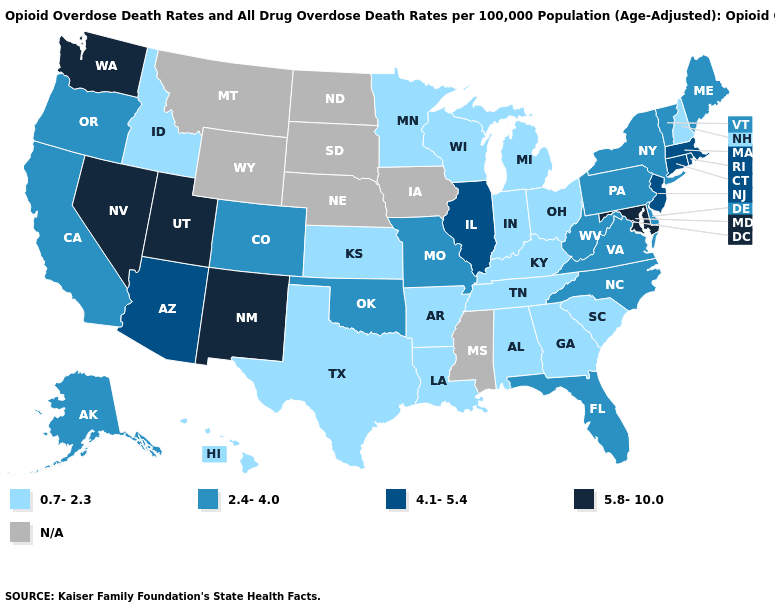What is the value of Louisiana?
Quick response, please. 0.7-2.3. Does the first symbol in the legend represent the smallest category?
Short answer required. Yes. Among the states that border Missouri , does Kentucky have the highest value?
Short answer required. No. What is the highest value in the USA?
Short answer required. 5.8-10.0. What is the highest value in states that border Maryland?
Answer briefly. 2.4-4.0. Is the legend a continuous bar?
Answer briefly. No. Does Kentucky have the lowest value in the USA?
Short answer required. Yes. What is the highest value in the USA?
Keep it brief. 5.8-10.0. What is the highest value in the USA?
Give a very brief answer. 5.8-10.0. Name the states that have a value in the range 2.4-4.0?
Write a very short answer. Alaska, California, Colorado, Delaware, Florida, Maine, Missouri, New York, North Carolina, Oklahoma, Oregon, Pennsylvania, Vermont, Virginia, West Virginia. What is the value of Nevada?
Answer briefly. 5.8-10.0. Name the states that have a value in the range 5.8-10.0?
Concise answer only. Maryland, Nevada, New Mexico, Utah, Washington. What is the value of Hawaii?
Give a very brief answer. 0.7-2.3. 